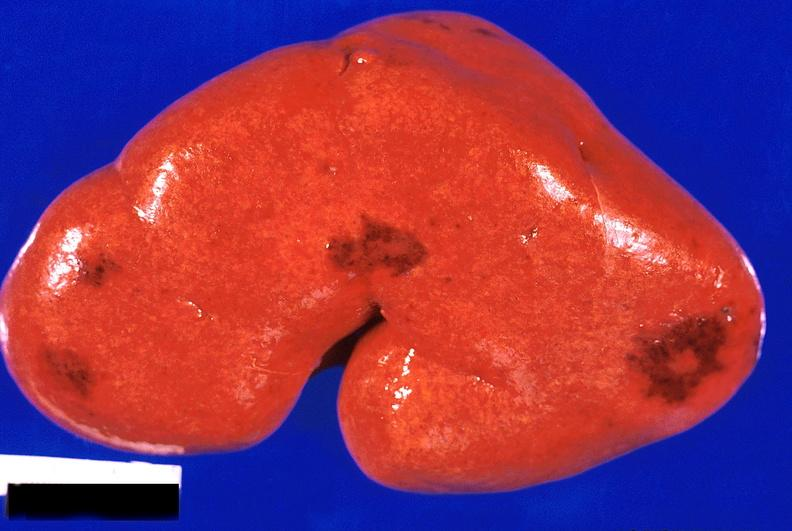what does this image show?
Answer the question using a single word or phrase. Kidney 